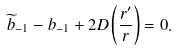Convert formula to latex. <formula><loc_0><loc_0><loc_500><loc_500>\widetilde { b } _ { - 1 } - b _ { - 1 } + 2 D \left ( \frac { r ^ { \prime } } { r } \right ) = 0 .</formula> 